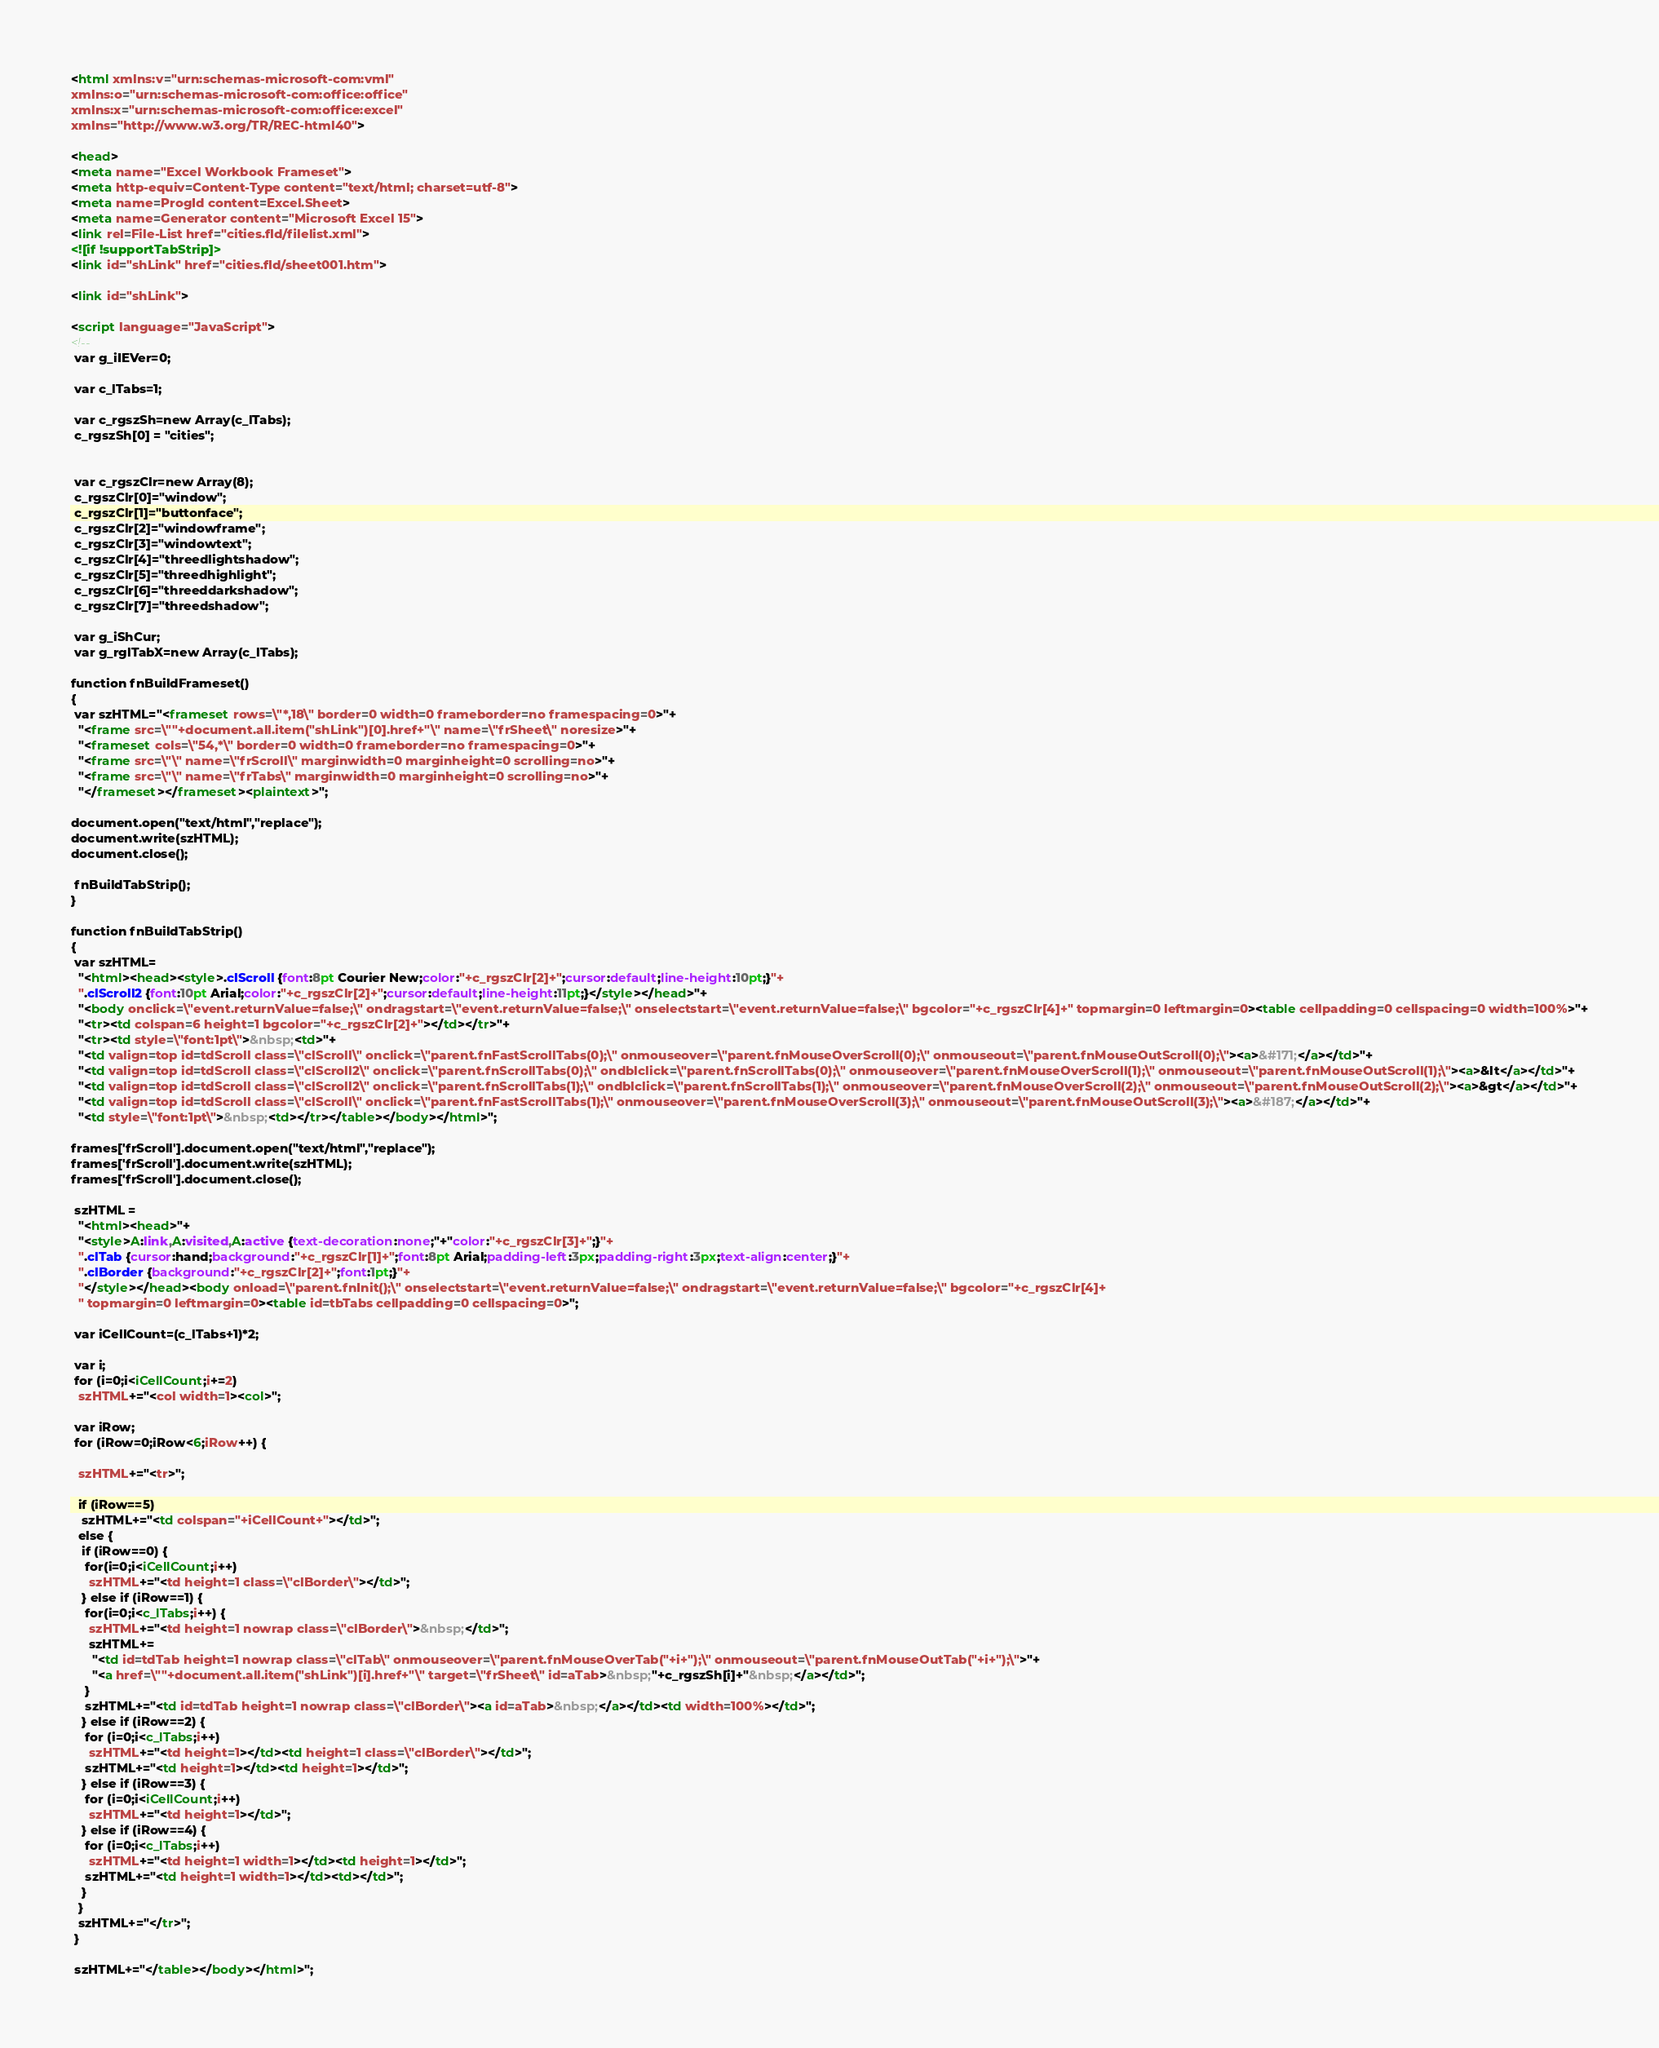Convert code to text. <code><loc_0><loc_0><loc_500><loc_500><_HTML_><html xmlns:v="urn:schemas-microsoft-com:vml"
xmlns:o="urn:schemas-microsoft-com:office:office"
xmlns:x="urn:schemas-microsoft-com:office:excel"
xmlns="http://www.w3.org/TR/REC-html40">

<head>
<meta name="Excel Workbook Frameset">
<meta http-equiv=Content-Type content="text/html; charset=utf-8">
<meta name=ProgId content=Excel.Sheet>
<meta name=Generator content="Microsoft Excel 15">
<link rel=File-List href="cities.fld/filelist.xml">
<![if !supportTabStrip]>
<link id="shLink" href="cities.fld/sheet001.htm">

<link id="shLink">

<script language="JavaScript">
<!--
 var g_iIEVer=0;
 
 var c_lTabs=1;

 var c_rgszSh=new Array(c_lTabs);
 c_rgszSh[0] = "cities";


 var c_rgszClr=new Array(8);
 c_rgszClr[0]="window";
 c_rgszClr[1]="buttonface";
 c_rgszClr[2]="windowframe";
 c_rgszClr[3]="windowtext";
 c_rgszClr[4]="threedlightshadow";
 c_rgszClr[5]="threedhighlight";
 c_rgszClr[6]="threeddarkshadow";
 c_rgszClr[7]="threedshadow";

 var g_iShCur;
 var g_rglTabX=new Array(c_lTabs);

function fnBuildFrameset()
{
 var szHTML="<frameset rows=\"*,18\" border=0 width=0 frameborder=no framespacing=0>"+
  "<frame src=\""+document.all.item("shLink")[0].href+"\" name=\"frSheet\" noresize>"+
  "<frameset cols=\"54,*\" border=0 width=0 frameborder=no framespacing=0>"+
  "<frame src=\"\" name=\"frScroll\" marginwidth=0 marginheight=0 scrolling=no>"+
  "<frame src=\"\" name=\"frTabs\" marginwidth=0 marginheight=0 scrolling=no>"+
  "</frameset></frameset><plaintext>";

document.open("text/html","replace");
document.write(szHTML);
document.close();

 fnBuildTabStrip();
}

function fnBuildTabStrip()
{
 var szHTML=
  "<html><head><style>.clScroll {font:8pt Courier New;color:"+c_rgszClr[2]+";cursor:default;line-height:10pt;}"+
  ".clScroll2 {font:10pt Arial;color:"+c_rgszClr[2]+";cursor:default;line-height:11pt;}</style></head>"+
  "<body onclick=\"event.returnValue=false;\" ondragstart=\"event.returnValue=false;\" onselectstart=\"event.returnValue=false;\" bgcolor="+c_rgszClr[4]+" topmargin=0 leftmargin=0><table cellpadding=0 cellspacing=0 width=100%>"+
  "<tr><td colspan=6 height=1 bgcolor="+c_rgszClr[2]+"></td></tr>"+
  "<tr><td style=\"font:1pt\">&nbsp;<td>"+
  "<td valign=top id=tdScroll class=\"clScroll\" onclick=\"parent.fnFastScrollTabs(0);\" onmouseover=\"parent.fnMouseOverScroll(0);\" onmouseout=\"parent.fnMouseOutScroll(0);\"><a>&#171;</a></td>"+
  "<td valign=top id=tdScroll class=\"clScroll2\" onclick=\"parent.fnScrollTabs(0);\" ondblclick=\"parent.fnScrollTabs(0);\" onmouseover=\"parent.fnMouseOverScroll(1);\" onmouseout=\"parent.fnMouseOutScroll(1);\"><a>&lt</a></td>"+
  "<td valign=top id=tdScroll class=\"clScroll2\" onclick=\"parent.fnScrollTabs(1);\" ondblclick=\"parent.fnScrollTabs(1);\" onmouseover=\"parent.fnMouseOverScroll(2);\" onmouseout=\"parent.fnMouseOutScroll(2);\"><a>&gt</a></td>"+
  "<td valign=top id=tdScroll class=\"clScroll\" onclick=\"parent.fnFastScrollTabs(1);\" onmouseover=\"parent.fnMouseOverScroll(3);\" onmouseout=\"parent.fnMouseOutScroll(3);\"><a>&#187;</a></td>"+
  "<td style=\"font:1pt\">&nbsp;<td></tr></table></body></html>";

frames['frScroll'].document.open("text/html","replace");
frames['frScroll'].document.write(szHTML);
frames['frScroll'].document.close();

 szHTML =
  "<html><head>"+
  "<style>A:link,A:visited,A:active {text-decoration:none;"+"color:"+c_rgszClr[3]+";}"+
  ".clTab {cursor:hand;background:"+c_rgszClr[1]+";font:8pt Arial;padding-left:3px;padding-right:3px;text-align:center;}"+
  ".clBorder {background:"+c_rgszClr[2]+";font:1pt;}"+
  "</style></head><body onload=\"parent.fnInit();\" onselectstart=\"event.returnValue=false;\" ondragstart=\"event.returnValue=false;\" bgcolor="+c_rgszClr[4]+
  " topmargin=0 leftmargin=0><table id=tbTabs cellpadding=0 cellspacing=0>";

 var iCellCount=(c_lTabs+1)*2;

 var i;
 for (i=0;i<iCellCount;i+=2)
  szHTML+="<col width=1><col>";

 var iRow;
 for (iRow=0;iRow<6;iRow++) {

  szHTML+="<tr>";

  if (iRow==5)
   szHTML+="<td colspan="+iCellCount+"></td>";
  else {
   if (iRow==0) {
    for(i=0;i<iCellCount;i++)
     szHTML+="<td height=1 class=\"clBorder\"></td>";
   } else if (iRow==1) {
    for(i=0;i<c_lTabs;i++) {
     szHTML+="<td height=1 nowrap class=\"clBorder\">&nbsp;</td>";
     szHTML+=
      "<td id=tdTab height=1 nowrap class=\"clTab\" onmouseover=\"parent.fnMouseOverTab("+i+");\" onmouseout=\"parent.fnMouseOutTab("+i+");\">"+
      "<a href=\""+document.all.item("shLink")[i].href+"\" target=\"frSheet\" id=aTab>&nbsp;"+c_rgszSh[i]+"&nbsp;</a></td>";
    }
    szHTML+="<td id=tdTab height=1 nowrap class=\"clBorder\"><a id=aTab>&nbsp;</a></td><td width=100%></td>";
   } else if (iRow==2) {
    for (i=0;i<c_lTabs;i++)
     szHTML+="<td height=1></td><td height=1 class=\"clBorder\"></td>";
    szHTML+="<td height=1></td><td height=1></td>";
   } else if (iRow==3) {
    for (i=0;i<iCellCount;i++)
     szHTML+="<td height=1></td>";
   } else if (iRow==4) {
    for (i=0;i<c_lTabs;i++)
     szHTML+="<td height=1 width=1></td><td height=1></td>";
    szHTML+="<td height=1 width=1></td><td></td>";
   }
  }
  szHTML+="</tr>";
 }

 szHTML+="</table></body></html>";
</code> 